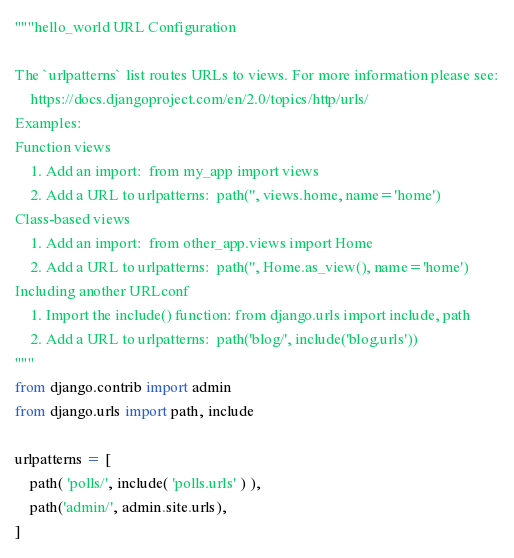<code> <loc_0><loc_0><loc_500><loc_500><_Python_>"""hello_world URL Configuration

The `urlpatterns` list routes URLs to views. For more information please see:
    https://docs.djangoproject.com/en/2.0/topics/http/urls/
Examples:
Function views
    1. Add an import:  from my_app import views
    2. Add a URL to urlpatterns:  path('', views.home, name='home')
Class-based views
    1. Add an import:  from other_app.views import Home
    2. Add a URL to urlpatterns:  path('', Home.as_view(), name='home')
Including another URLconf
    1. Import the include() function: from django.urls import include, path
    2. Add a URL to urlpatterns:  path('blog/', include('blog.urls'))
"""
from django.contrib import admin
from django.urls import path, include

urlpatterns = [
	path( 'polls/', include( 'polls.urls' ) ),
	path('admin/', admin.site.urls),
]

</code> 